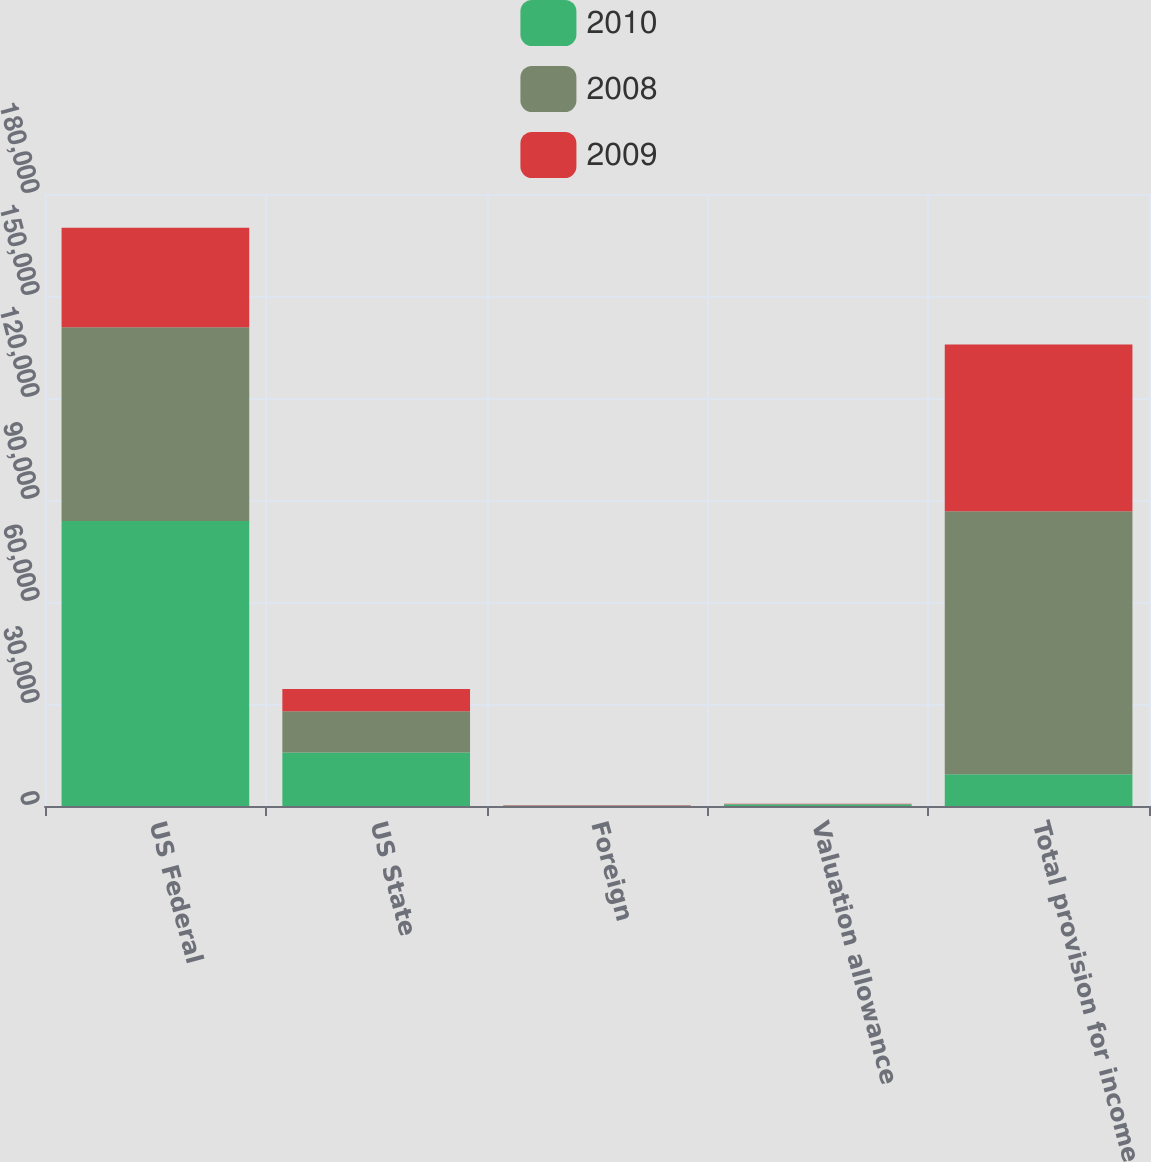Convert chart. <chart><loc_0><loc_0><loc_500><loc_500><stacked_bar_chart><ecel><fcel>US Federal<fcel>US State<fcel>Foreign<fcel>Valuation allowance<fcel>Total provision for income<nl><fcel>2010<fcel>83850<fcel>15745<fcel>6<fcel>415<fcel>9331.5<nl><fcel>2008<fcel>56945<fcel>12151<fcel>139<fcel>141<fcel>77380<nl><fcel>2009<fcel>29291<fcel>6512<fcel>53<fcel>89<fcel>49004<nl></chart> 